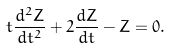<formula> <loc_0><loc_0><loc_500><loc_500>t \frac { d ^ { 2 } Z } { d t ^ { 2 } } + 2 \frac { d Z } { d t } - Z = 0 .</formula> 